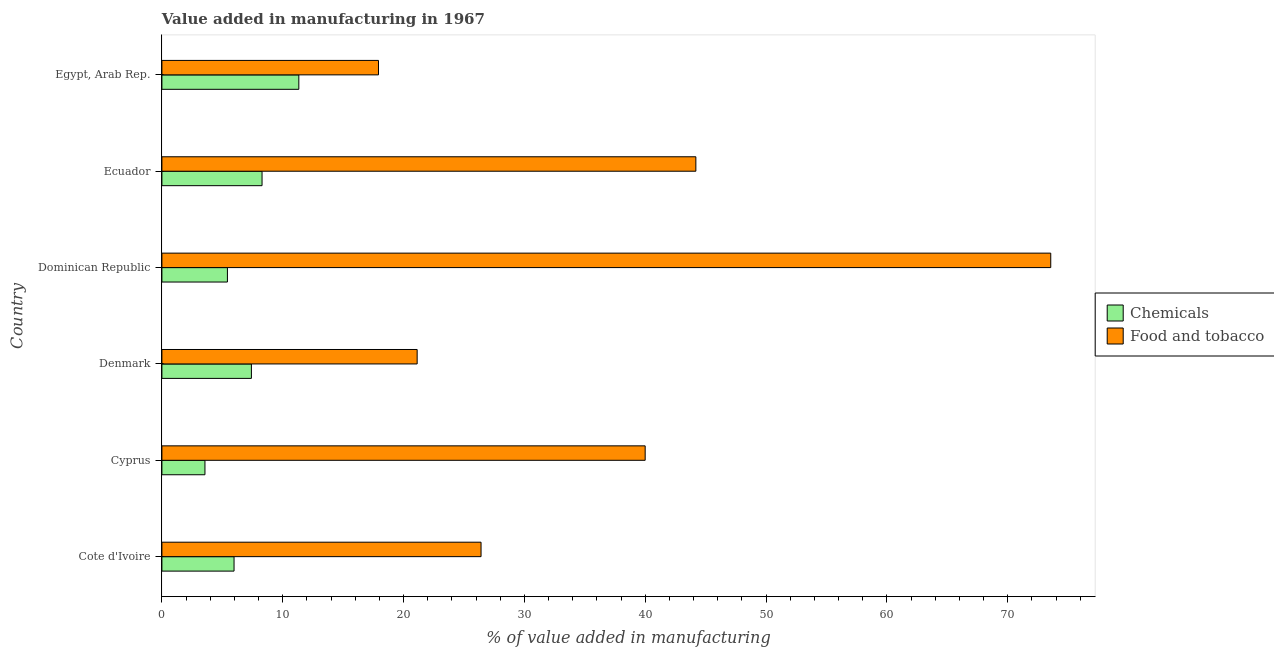How many different coloured bars are there?
Ensure brevity in your answer.  2. How many bars are there on the 2nd tick from the bottom?
Give a very brief answer. 2. What is the label of the 1st group of bars from the top?
Your answer should be compact. Egypt, Arab Rep. In how many cases, is the number of bars for a given country not equal to the number of legend labels?
Make the answer very short. 0. What is the value added by  manufacturing chemicals in Ecuador?
Your answer should be very brief. 8.29. Across all countries, what is the maximum value added by manufacturing food and tobacco?
Offer a terse response. 73.55. Across all countries, what is the minimum value added by  manufacturing chemicals?
Keep it short and to the point. 3.56. In which country was the value added by  manufacturing chemicals maximum?
Provide a short and direct response. Egypt, Arab Rep. In which country was the value added by  manufacturing chemicals minimum?
Give a very brief answer. Cyprus. What is the total value added by manufacturing food and tobacco in the graph?
Your response must be concise. 223.19. What is the difference between the value added by manufacturing food and tobacco in Cote d'Ivoire and that in Egypt, Arab Rep.?
Offer a very short reply. 8.49. What is the difference between the value added by manufacturing food and tobacco in Dominican Republic and the value added by  manufacturing chemicals in Egypt, Arab Rep.?
Provide a short and direct response. 62.22. What is the average value added by  manufacturing chemicals per country?
Provide a succinct answer. 7. What is the difference between the value added by manufacturing food and tobacco and value added by  manufacturing chemicals in Egypt, Arab Rep.?
Your response must be concise. 6.59. In how many countries, is the value added by  manufacturing chemicals greater than 8 %?
Provide a succinct answer. 2. What is the ratio of the value added by manufacturing food and tobacco in Denmark to that in Egypt, Arab Rep.?
Provide a succinct answer. 1.18. Is the value added by manufacturing food and tobacco in Cyprus less than that in Dominican Republic?
Keep it short and to the point. Yes. Is the difference between the value added by manufacturing food and tobacco in Denmark and Dominican Republic greater than the difference between the value added by  manufacturing chemicals in Denmark and Dominican Republic?
Make the answer very short. No. What is the difference between the highest and the second highest value added by manufacturing food and tobacco?
Offer a terse response. 29.37. What is the difference between the highest and the lowest value added by  manufacturing chemicals?
Make the answer very short. 7.77. In how many countries, is the value added by  manufacturing chemicals greater than the average value added by  manufacturing chemicals taken over all countries?
Your answer should be very brief. 3. What does the 1st bar from the top in Ecuador represents?
Provide a succinct answer. Food and tobacco. What does the 1st bar from the bottom in Ecuador represents?
Your answer should be very brief. Chemicals. How many bars are there?
Provide a short and direct response. 12. Are all the bars in the graph horizontal?
Make the answer very short. Yes. How many countries are there in the graph?
Offer a very short reply. 6. Does the graph contain any zero values?
Offer a very short reply. No. What is the title of the graph?
Your response must be concise. Value added in manufacturing in 1967. Does "Tetanus" appear as one of the legend labels in the graph?
Your response must be concise. No. What is the label or title of the X-axis?
Your answer should be very brief. % of value added in manufacturing. What is the % of value added in manufacturing in Chemicals in Cote d'Ivoire?
Your answer should be very brief. 5.97. What is the % of value added in manufacturing in Food and tobacco in Cote d'Ivoire?
Ensure brevity in your answer.  26.41. What is the % of value added in manufacturing in Chemicals in Cyprus?
Provide a succinct answer. 3.56. What is the % of value added in manufacturing of Food and tobacco in Cyprus?
Give a very brief answer. 39.99. What is the % of value added in manufacturing in Chemicals in Denmark?
Give a very brief answer. 7.41. What is the % of value added in manufacturing of Food and tobacco in Denmark?
Give a very brief answer. 21.12. What is the % of value added in manufacturing in Chemicals in Dominican Republic?
Give a very brief answer. 5.42. What is the % of value added in manufacturing in Food and tobacco in Dominican Republic?
Your answer should be compact. 73.55. What is the % of value added in manufacturing of Chemicals in Ecuador?
Provide a succinct answer. 8.29. What is the % of value added in manufacturing of Food and tobacco in Ecuador?
Your answer should be very brief. 44.19. What is the % of value added in manufacturing of Chemicals in Egypt, Arab Rep.?
Offer a terse response. 11.33. What is the % of value added in manufacturing in Food and tobacco in Egypt, Arab Rep.?
Provide a short and direct response. 17.92. Across all countries, what is the maximum % of value added in manufacturing in Chemicals?
Provide a short and direct response. 11.33. Across all countries, what is the maximum % of value added in manufacturing of Food and tobacco?
Keep it short and to the point. 73.55. Across all countries, what is the minimum % of value added in manufacturing of Chemicals?
Ensure brevity in your answer.  3.56. Across all countries, what is the minimum % of value added in manufacturing in Food and tobacco?
Ensure brevity in your answer.  17.92. What is the total % of value added in manufacturing of Chemicals in the graph?
Make the answer very short. 41.98. What is the total % of value added in manufacturing of Food and tobacco in the graph?
Offer a very short reply. 223.19. What is the difference between the % of value added in manufacturing of Chemicals in Cote d'Ivoire and that in Cyprus?
Offer a very short reply. 2.41. What is the difference between the % of value added in manufacturing of Food and tobacco in Cote d'Ivoire and that in Cyprus?
Your answer should be compact. -13.58. What is the difference between the % of value added in manufacturing of Chemicals in Cote d'Ivoire and that in Denmark?
Your answer should be very brief. -1.44. What is the difference between the % of value added in manufacturing of Food and tobacco in Cote d'Ivoire and that in Denmark?
Offer a terse response. 5.29. What is the difference between the % of value added in manufacturing in Chemicals in Cote d'Ivoire and that in Dominican Republic?
Your answer should be very brief. 0.55. What is the difference between the % of value added in manufacturing of Food and tobacco in Cote d'Ivoire and that in Dominican Republic?
Your answer should be compact. -47.14. What is the difference between the % of value added in manufacturing in Chemicals in Cote d'Ivoire and that in Ecuador?
Your response must be concise. -2.32. What is the difference between the % of value added in manufacturing of Food and tobacco in Cote d'Ivoire and that in Ecuador?
Make the answer very short. -17.78. What is the difference between the % of value added in manufacturing in Chemicals in Cote d'Ivoire and that in Egypt, Arab Rep.?
Provide a short and direct response. -5.36. What is the difference between the % of value added in manufacturing of Food and tobacco in Cote d'Ivoire and that in Egypt, Arab Rep.?
Offer a terse response. 8.49. What is the difference between the % of value added in manufacturing of Chemicals in Cyprus and that in Denmark?
Give a very brief answer. -3.84. What is the difference between the % of value added in manufacturing in Food and tobacco in Cyprus and that in Denmark?
Your answer should be compact. 18.87. What is the difference between the % of value added in manufacturing in Chemicals in Cyprus and that in Dominican Republic?
Offer a very short reply. -1.86. What is the difference between the % of value added in manufacturing of Food and tobacco in Cyprus and that in Dominican Republic?
Offer a terse response. -33.56. What is the difference between the % of value added in manufacturing in Chemicals in Cyprus and that in Ecuador?
Offer a terse response. -4.72. What is the difference between the % of value added in manufacturing in Food and tobacco in Cyprus and that in Ecuador?
Your answer should be compact. -4.19. What is the difference between the % of value added in manufacturing in Chemicals in Cyprus and that in Egypt, Arab Rep.?
Ensure brevity in your answer.  -7.77. What is the difference between the % of value added in manufacturing of Food and tobacco in Cyprus and that in Egypt, Arab Rep.?
Keep it short and to the point. 22.07. What is the difference between the % of value added in manufacturing in Chemicals in Denmark and that in Dominican Republic?
Provide a short and direct response. 1.99. What is the difference between the % of value added in manufacturing in Food and tobacco in Denmark and that in Dominican Republic?
Your answer should be very brief. -52.43. What is the difference between the % of value added in manufacturing of Chemicals in Denmark and that in Ecuador?
Ensure brevity in your answer.  -0.88. What is the difference between the % of value added in manufacturing of Food and tobacco in Denmark and that in Ecuador?
Your answer should be very brief. -23.06. What is the difference between the % of value added in manufacturing of Chemicals in Denmark and that in Egypt, Arab Rep.?
Your answer should be compact. -3.92. What is the difference between the % of value added in manufacturing of Food and tobacco in Denmark and that in Egypt, Arab Rep.?
Make the answer very short. 3.2. What is the difference between the % of value added in manufacturing in Chemicals in Dominican Republic and that in Ecuador?
Provide a short and direct response. -2.87. What is the difference between the % of value added in manufacturing of Food and tobacco in Dominican Republic and that in Ecuador?
Offer a terse response. 29.37. What is the difference between the % of value added in manufacturing in Chemicals in Dominican Republic and that in Egypt, Arab Rep.?
Provide a succinct answer. -5.91. What is the difference between the % of value added in manufacturing in Food and tobacco in Dominican Republic and that in Egypt, Arab Rep.?
Provide a succinct answer. 55.63. What is the difference between the % of value added in manufacturing in Chemicals in Ecuador and that in Egypt, Arab Rep.?
Your answer should be very brief. -3.04. What is the difference between the % of value added in manufacturing of Food and tobacco in Ecuador and that in Egypt, Arab Rep.?
Provide a succinct answer. 26.26. What is the difference between the % of value added in manufacturing in Chemicals in Cote d'Ivoire and the % of value added in manufacturing in Food and tobacco in Cyprus?
Ensure brevity in your answer.  -34.02. What is the difference between the % of value added in manufacturing in Chemicals in Cote d'Ivoire and the % of value added in manufacturing in Food and tobacco in Denmark?
Provide a short and direct response. -15.15. What is the difference between the % of value added in manufacturing of Chemicals in Cote d'Ivoire and the % of value added in manufacturing of Food and tobacco in Dominican Republic?
Your response must be concise. -67.58. What is the difference between the % of value added in manufacturing of Chemicals in Cote d'Ivoire and the % of value added in manufacturing of Food and tobacco in Ecuador?
Provide a succinct answer. -38.22. What is the difference between the % of value added in manufacturing in Chemicals in Cote d'Ivoire and the % of value added in manufacturing in Food and tobacco in Egypt, Arab Rep.?
Offer a very short reply. -11.95. What is the difference between the % of value added in manufacturing in Chemicals in Cyprus and the % of value added in manufacturing in Food and tobacco in Denmark?
Make the answer very short. -17.56. What is the difference between the % of value added in manufacturing in Chemicals in Cyprus and the % of value added in manufacturing in Food and tobacco in Dominican Republic?
Your response must be concise. -69.99. What is the difference between the % of value added in manufacturing in Chemicals in Cyprus and the % of value added in manufacturing in Food and tobacco in Ecuador?
Offer a terse response. -40.62. What is the difference between the % of value added in manufacturing in Chemicals in Cyprus and the % of value added in manufacturing in Food and tobacco in Egypt, Arab Rep.?
Offer a very short reply. -14.36. What is the difference between the % of value added in manufacturing in Chemicals in Denmark and the % of value added in manufacturing in Food and tobacco in Dominican Republic?
Your answer should be very brief. -66.15. What is the difference between the % of value added in manufacturing in Chemicals in Denmark and the % of value added in manufacturing in Food and tobacco in Ecuador?
Make the answer very short. -36.78. What is the difference between the % of value added in manufacturing in Chemicals in Denmark and the % of value added in manufacturing in Food and tobacco in Egypt, Arab Rep.?
Offer a very short reply. -10.52. What is the difference between the % of value added in manufacturing of Chemicals in Dominican Republic and the % of value added in manufacturing of Food and tobacco in Ecuador?
Your answer should be compact. -38.76. What is the difference between the % of value added in manufacturing of Chemicals in Dominican Republic and the % of value added in manufacturing of Food and tobacco in Egypt, Arab Rep.?
Offer a terse response. -12.5. What is the difference between the % of value added in manufacturing of Chemicals in Ecuador and the % of value added in manufacturing of Food and tobacco in Egypt, Arab Rep.?
Provide a short and direct response. -9.64. What is the average % of value added in manufacturing of Chemicals per country?
Your answer should be very brief. 7. What is the average % of value added in manufacturing of Food and tobacco per country?
Provide a succinct answer. 37.2. What is the difference between the % of value added in manufacturing in Chemicals and % of value added in manufacturing in Food and tobacco in Cote d'Ivoire?
Provide a short and direct response. -20.44. What is the difference between the % of value added in manufacturing in Chemicals and % of value added in manufacturing in Food and tobacco in Cyprus?
Offer a terse response. -36.43. What is the difference between the % of value added in manufacturing in Chemicals and % of value added in manufacturing in Food and tobacco in Denmark?
Ensure brevity in your answer.  -13.72. What is the difference between the % of value added in manufacturing in Chemicals and % of value added in manufacturing in Food and tobacco in Dominican Republic?
Ensure brevity in your answer.  -68.13. What is the difference between the % of value added in manufacturing in Chemicals and % of value added in manufacturing in Food and tobacco in Ecuador?
Provide a short and direct response. -35.9. What is the difference between the % of value added in manufacturing in Chemicals and % of value added in manufacturing in Food and tobacco in Egypt, Arab Rep.?
Give a very brief answer. -6.59. What is the ratio of the % of value added in manufacturing of Chemicals in Cote d'Ivoire to that in Cyprus?
Provide a succinct answer. 1.68. What is the ratio of the % of value added in manufacturing in Food and tobacco in Cote d'Ivoire to that in Cyprus?
Your answer should be compact. 0.66. What is the ratio of the % of value added in manufacturing of Chemicals in Cote d'Ivoire to that in Denmark?
Make the answer very short. 0.81. What is the ratio of the % of value added in manufacturing of Food and tobacco in Cote d'Ivoire to that in Denmark?
Keep it short and to the point. 1.25. What is the ratio of the % of value added in manufacturing in Chemicals in Cote d'Ivoire to that in Dominican Republic?
Your answer should be very brief. 1.1. What is the ratio of the % of value added in manufacturing of Food and tobacco in Cote d'Ivoire to that in Dominican Republic?
Keep it short and to the point. 0.36. What is the ratio of the % of value added in manufacturing of Chemicals in Cote d'Ivoire to that in Ecuador?
Ensure brevity in your answer.  0.72. What is the ratio of the % of value added in manufacturing in Food and tobacco in Cote d'Ivoire to that in Ecuador?
Provide a short and direct response. 0.6. What is the ratio of the % of value added in manufacturing in Chemicals in Cote d'Ivoire to that in Egypt, Arab Rep.?
Make the answer very short. 0.53. What is the ratio of the % of value added in manufacturing of Food and tobacco in Cote d'Ivoire to that in Egypt, Arab Rep.?
Provide a succinct answer. 1.47. What is the ratio of the % of value added in manufacturing in Chemicals in Cyprus to that in Denmark?
Your answer should be very brief. 0.48. What is the ratio of the % of value added in manufacturing in Food and tobacco in Cyprus to that in Denmark?
Ensure brevity in your answer.  1.89. What is the ratio of the % of value added in manufacturing in Chemicals in Cyprus to that in Dominican Republic?
Your answer should be very brief. 0.66. What is the ratio of the % of value added in manufacturing of Food and tobacco in Cyprus to that in Dominican Republic?
Give a very brief answer. 0.54. What is the ratio of the % of value added in manufacturing of Chemicals in Cyprus to that in Ecuador?
Your answer should be compact. 0.43. What is the ratio of the % of value added in manufacturing in Food and tobacco in Cyprus to that in Ecuador?
Your answer should be compact. 0.91. What is the ratio of the % of value added in manufacturing of Chemicals in Cyprus to that in Egypt, Arab Rep.?
Ensure brevity in your answer.  0.31. What is the ratio of the % of value added in manufacturing in Food and tobacco in Cyprus to that in Egypt, Arab Rep.?
Give a very brief answer. 2.23. What is the ratio of the % of value added in manufacturing of Chemicals in Denmark to that in Dominican Republic?
Your answer should be very brief. 1.37. What is the ratio of the % of value added in manufacturing of Food and tobacco in Denmark to that in Dominican Republic?
Your answer should be very brief. 0.29. What is the ratio of the % of value added in manufacturing of Chemicals in Denmark to that in Ecuador?
Your response must be concise. 0.89. What is the ratio of the % of value added in manufacturing in Food and tobacco in Denmark to that in Ecuador?
Your response must be concise. 0.48. What is the ratio of the % of value added in manufacturing in Chemicals in Denmark to that in Egypt, Arab Rep.?
Provide a short and direct response. 0.65. What is the ratio of the % of value added in manufacturing in Food and tobacco in Denmark to that in Egypt, Arab Rep.?
Make the answer very short. 1.18. What is the ratio of the % of value added in manufacturing of Chemicals in Dominican Republic to that in Ecuador?
Your answer should be very brief. 0.65. What is the ratio of the % of value added in manufacturing in Food and tobacco in Dominican Republic to that in Ecuador?
Provide a succinct answer. 1.66. What is the ratio of the % of value added in manufacturing of Chemicals in Dominican Republic to that in Egypt, Arab Rep.?
Your answer should be very brief. 0.48. What is the ratio of the % of value added in manufacturing in Food and tobacco in Dominican Republic to that in Egypt, Arab Rep.?
Provide a succinct answer. 4.1. What is the ratio of the % of value added in manufacturing in Chemicals in Ecuador to that in Egypt, Arab Rep.?
Make the answer very short. 0.73. What is the ratio of the % of value added in manufacturing in Food and tobacco in Ecuador to that in Egypt, Arab Rep.?
Give a very brief answer. 2.47. What is the difference between the highest and the second highest % of value added in manufacturing in Chemicals?
Provide a succinct answer. 3.04. What is the difference between the highest and the second highest % of value added in manufacturing in Food and tobacco?
Provide a succinct answer. 29.37. What is the difference between the highest and the lowest % of value added in manufacturing in Chemicals?
Give a very brief answer. 7.77. What is the difference between the highest and the lowest % of value added in manufacturing in Food and tobacco?
Provide a short and direct response. 55.63. 